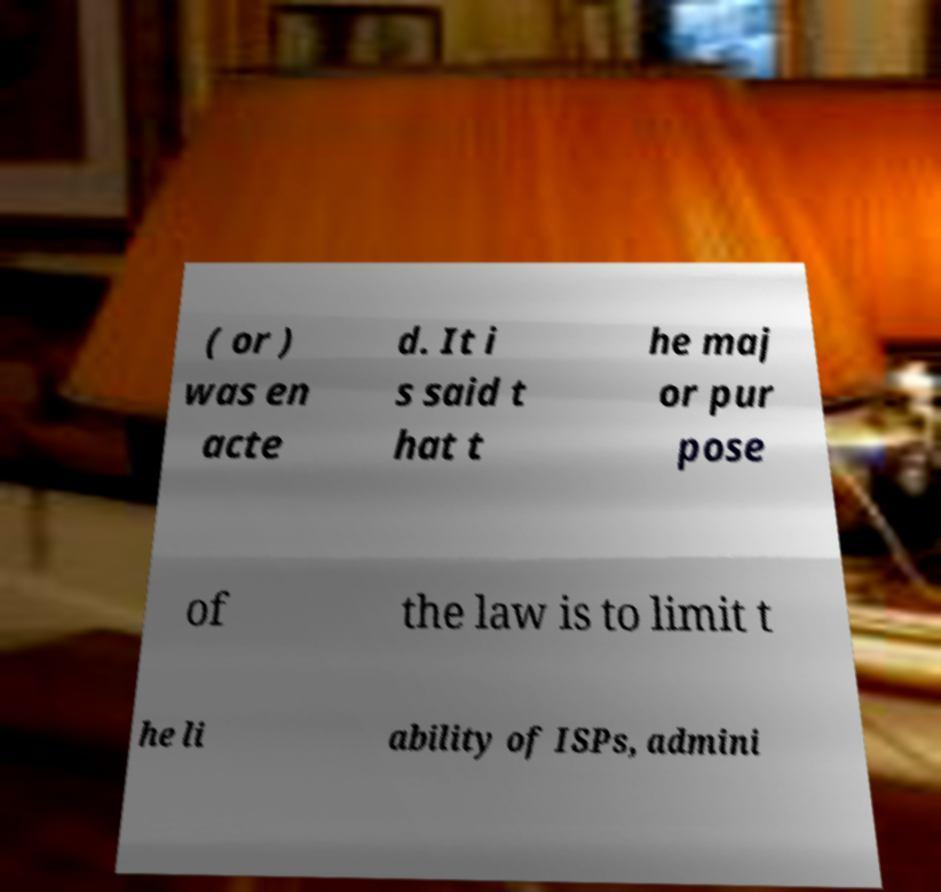Could you assist in decoding the text presented in this image and type it out clearly? ( or ) was en acte d. It i s said t hat t he maj or pur pose of the law is to limit t he li ability of ISPs, admini 